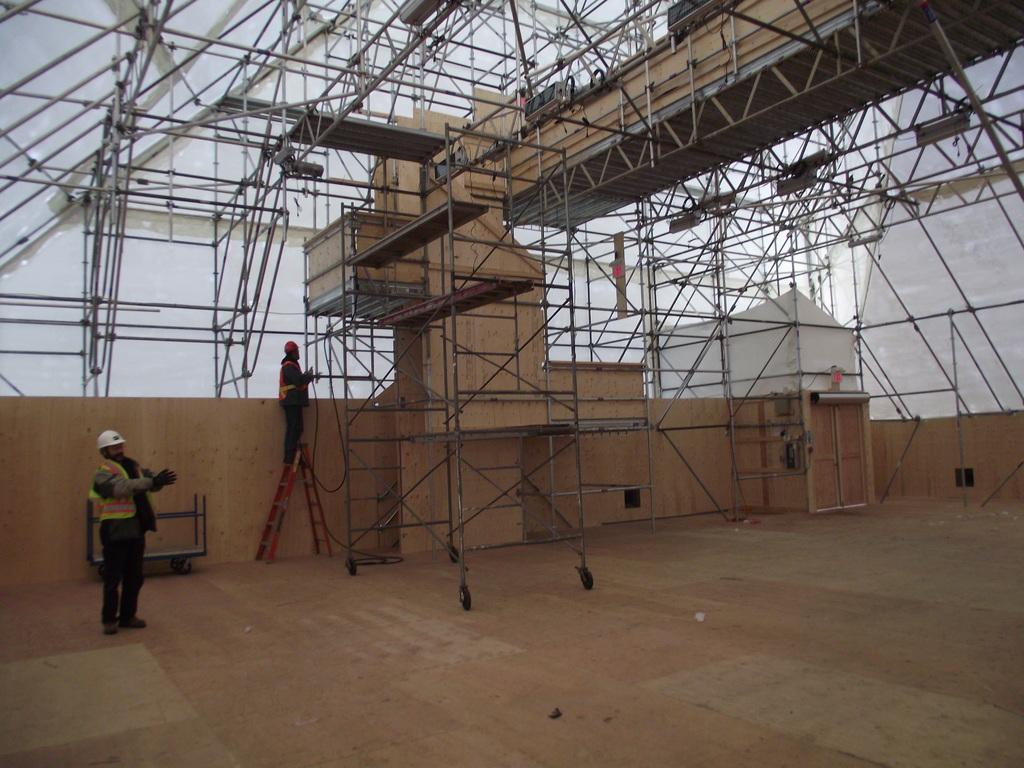Could you give a brief overview of what you see in this image? In this image, we can see two people standing, one of them is standing on the ladder and in the background, we can see beam. 